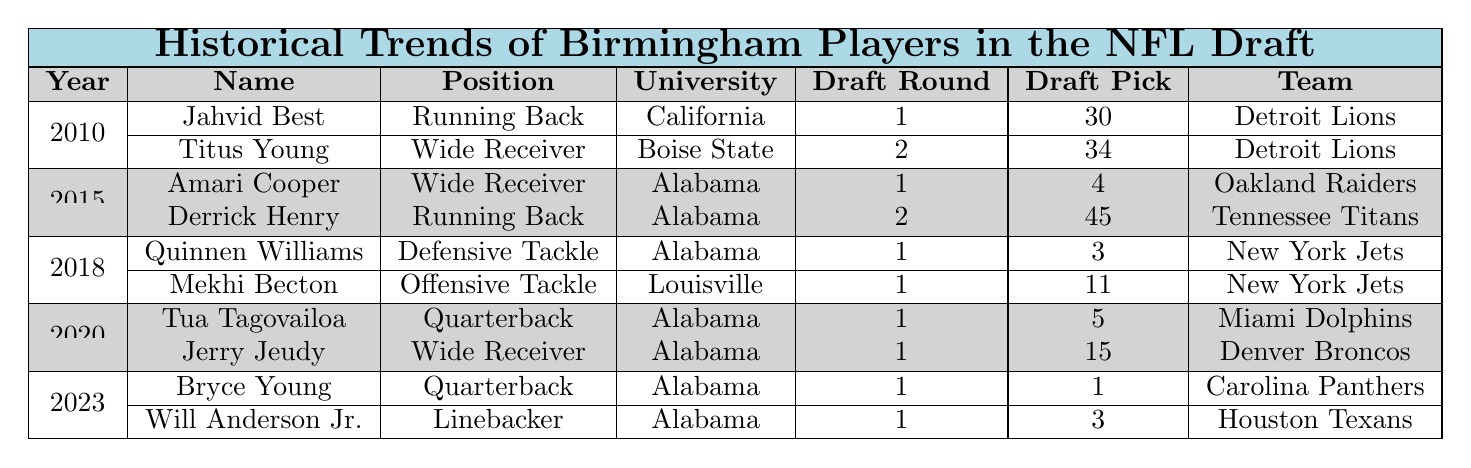What positions did players from Alabama occupy in the 2020 NFL Draft? Looking at the 2020 row in the table, the players drafted were Tua Tagovailoa as Quarterback and Jerry Jeudy as Wide Receiver. Both positions are clearly listed next to their names.
Answer: Quarterback and Wide Receiver Which player was the first overall pick in the NFL Draft from Alabama? In the 2023 row, Bryce Young is noted as a Quarterback and was drafted with the first pick overall, as indicated in the Draft Pick column.
Answer: Bryce Young How many players from Alabama were drafted in the year 2015? Referring to the year 2015, there are two players listed: Amari Cooper and Derrick Henry, so we count them.
Answer: 2 What is the highest draft round achieved by a Birmingham player in the given years? The years listed show multiple players drafted in the first round including Amari Cooper, Quinnen Williams, Tua Tagovailoa, and Bryce Young. The highest draft round is 1.
Answer: 1 Did any player from the University of Louisville get drafted in 2018? In the table under the year 2018, there is one player listed from the University of Louisville: Mekhi Becton. Therefore, the answer is yes.
Answer: Yes What is the average draft position of Alabama players across all listed drafts? Adding the draft picks of Alabama players: 4 (Amari Cooper) + 45 (Derrick Henry) + 3 (Quinnen Williams) + 5 (Tua Tagovailoa) + 1 (Bryce Young) gives us a total of 58. Dividing by the 5 Alabama players drafted gives an average of 58/5 = 11.6.
Answer: 11.6 How many total players were drafted in the 2023 NFL Draft according to the table? From the 2023 row, we see there are two players listed: Bryce Young and Will Anderson Jr. So, we simply count them.
Answer: 2 Which team drafted the highest number of players in the years presented? Reviewing the table, the Detroit Lions drafted 2 players in 2010, and the New York Jets also drafted 2 players in 2018. No other teams drafted more than 2 players as seen from the table.
Answer: 2 